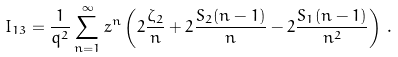Convert formula to latex. <formula><loc_0><loc_0><loc_500><loc_500>I _ { 1 3 } = \frac { 1 } { q ^ { 2 } } \sum _ { n = 1 } ^ { \infty } z ^ { n } \left ( 2 \frac { \zeta _ { 2 } } { n } + 2 \frac { S _ { 2 } ( n - 1 ) } { n } - 2 \frac { S _ { 1 } ( n - 1 ) } { n ^ { 2 } } \right ) \, .</formula> 